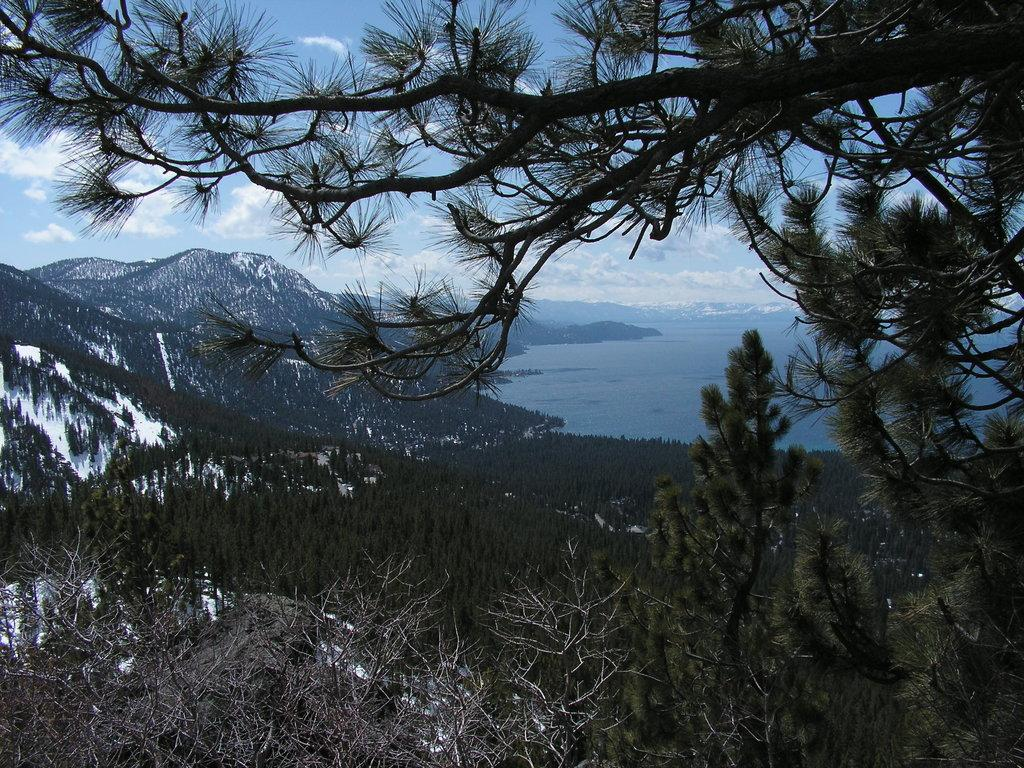What type of vegetation can be seen in the image? There are trees in the image. What is located on the right side of the image? There is water on the right side of the image. What can be seen in the distance in the image? There are hills visible in the background of the image. What is visible in the top part of the image? The sky is visible in the image. What can be observed in the sky? Clouds are present in the sky. Can you find the key that is hidden in the trees in the image? There is no key hidden in the trees in the image. Is there a club visible in the image? There is no club present in the image. 